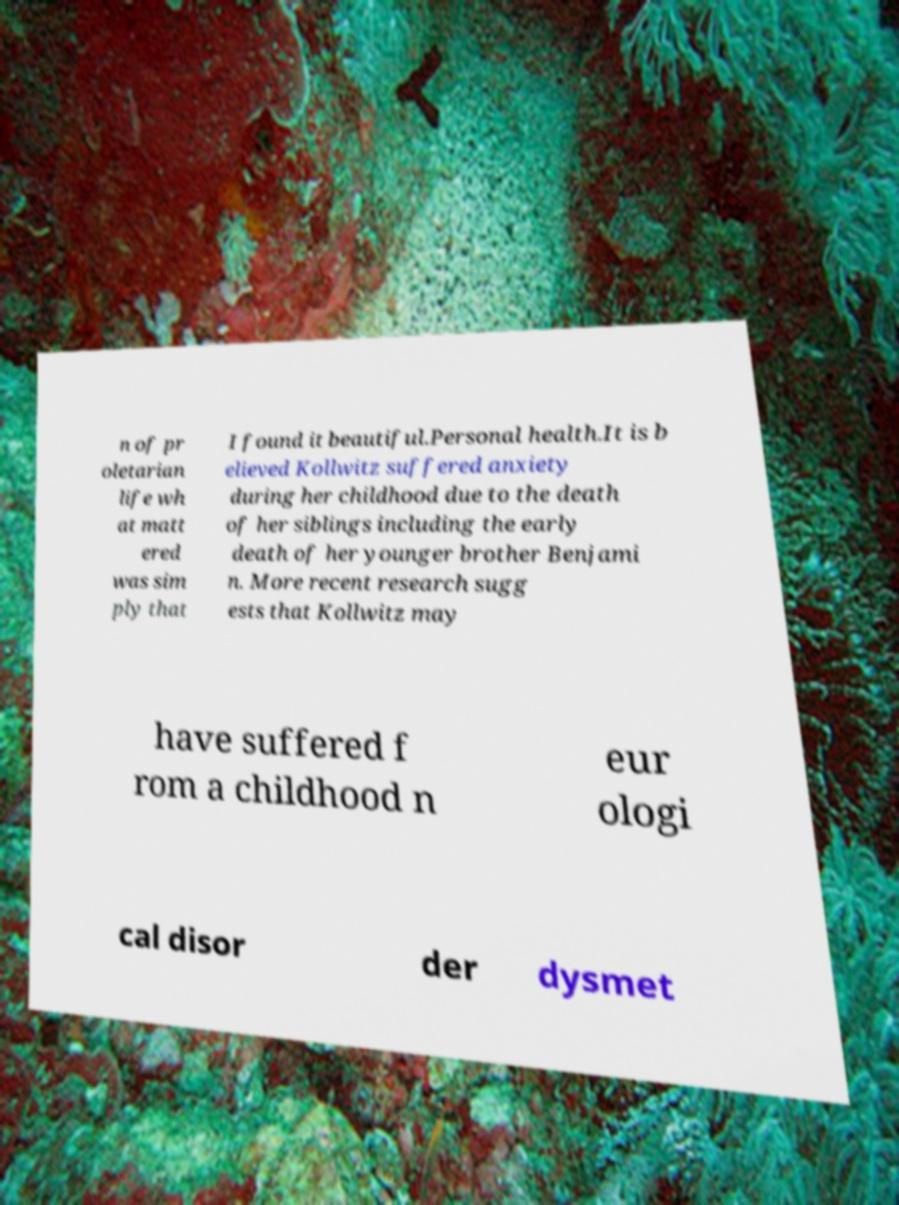There's text embedded in this image that I need extracted. Can you transcribe it verbatim? n of pr oletarian life wh at matt ered was sim ply that I found it beautiful.Personal health.It is b elieved Kollwitz suffered anxiety during her childhood due to the death of her siblings including the early death of her younger brother Benjami n. More recent research sugg ests that Kollwitz may have suffered f rom a childhood n eur ologi cal disor der dysmet 